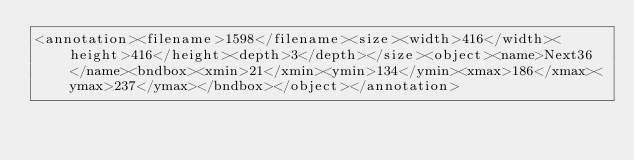<code> <loc_0><loc_0><loc_500><loc_500><_XML_><annotation><filename>1598</filename><size><width>416</width><height>416</height><depth>3</depth></size><object><name>Next36</name><bndbox><xmin>21</xmin><ymin>134</ymin><xmax>186</xmax><ymax>237</ymax></bndbox></object></annotation></code> 